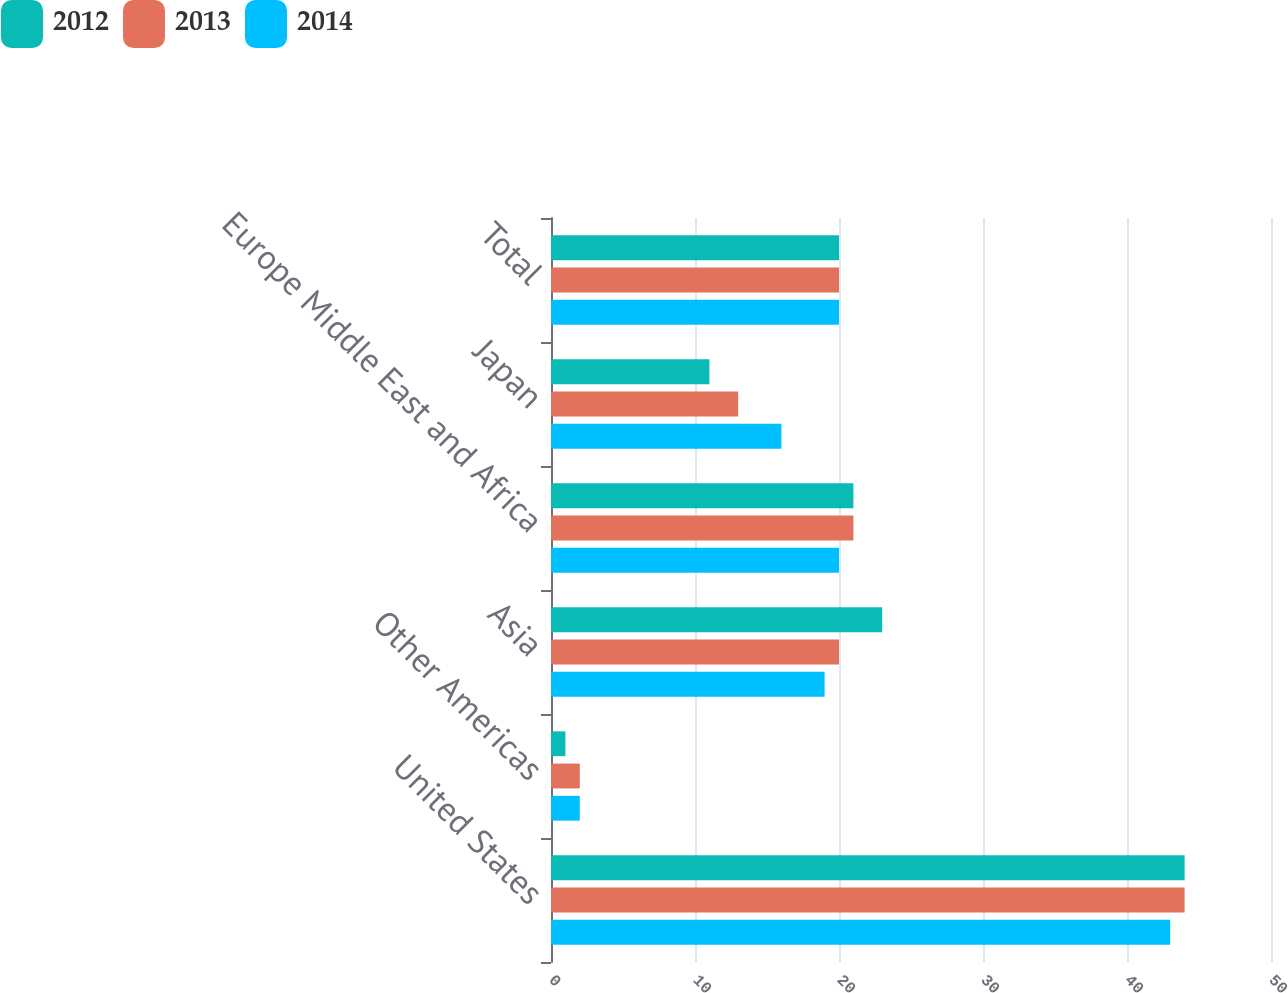Convert chart to OTSL. <chart><loc_0><loc_0><loc_500><loc_500><stacked_bar_chart><ecel><fcel>United States<fcel>Other Americas<fcel>Asia<fcel>Europe Middle East and Africa<fcel>Japan<fcel>Total<nl><fcel>2012<fcel>44<fcel>1<fcel>23<fcel>21<fcel>11<fcel>20<nl><fcel>2013<fcel>44<fcel>2<fcel>20<fcel>21<fcel>13<fcel>20<nl><fcel>2014<fcel>43<fcel>2<fcel>19<fcel>20<fcel>16<fcel>20<nl></chart> 